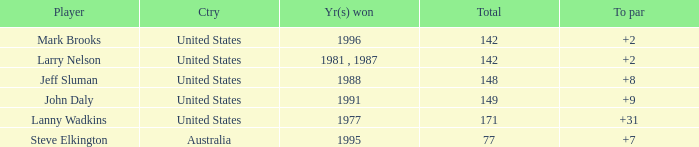Name the To par that has a Year(s) won of 1988 and a Total smaller than 148? None. 